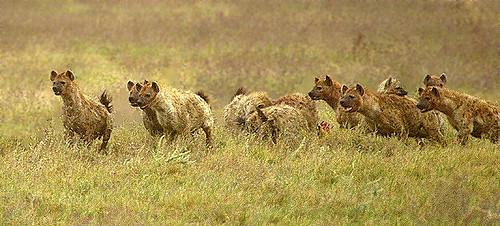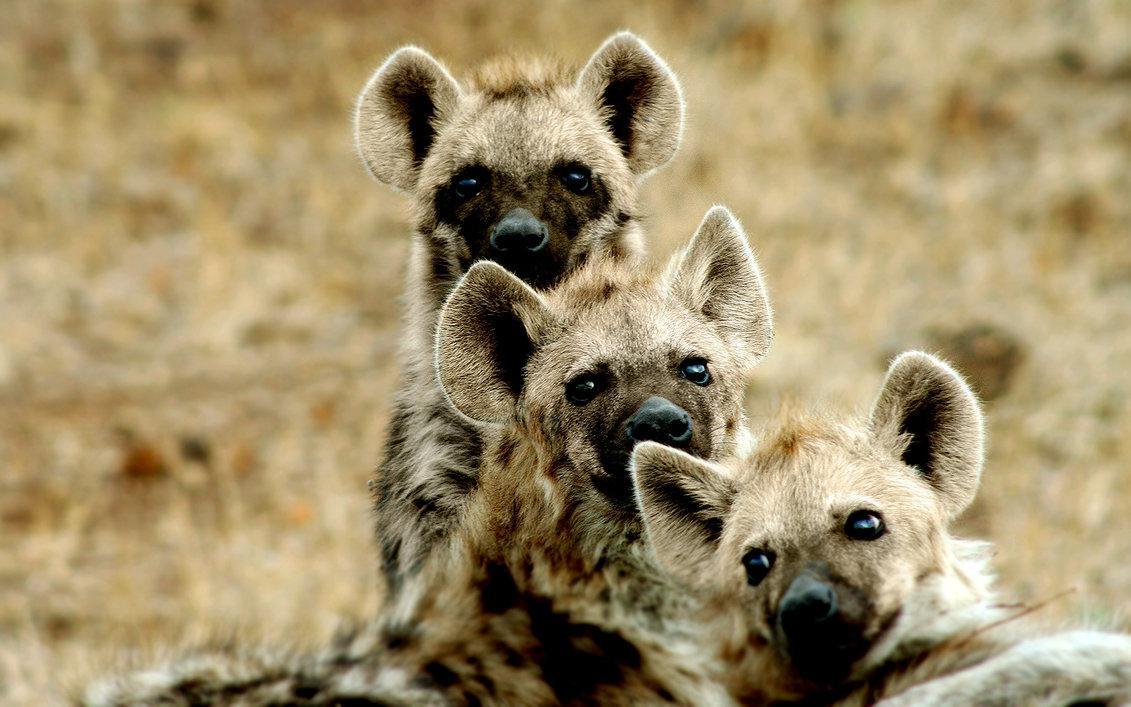The first image is the image on the left, the second image is the image on the right. For the images displayed, is the sentence "There is a single hyena in the image on the left." factually correct? Answer yes or no. No. The first image is the image on the left, the second image is the image on the right. Examine the images to the left and right. Is the description "The lefthand image contains a single hyena, and the right image contains at least four hyena." accurate? Answer yes or no. No. 